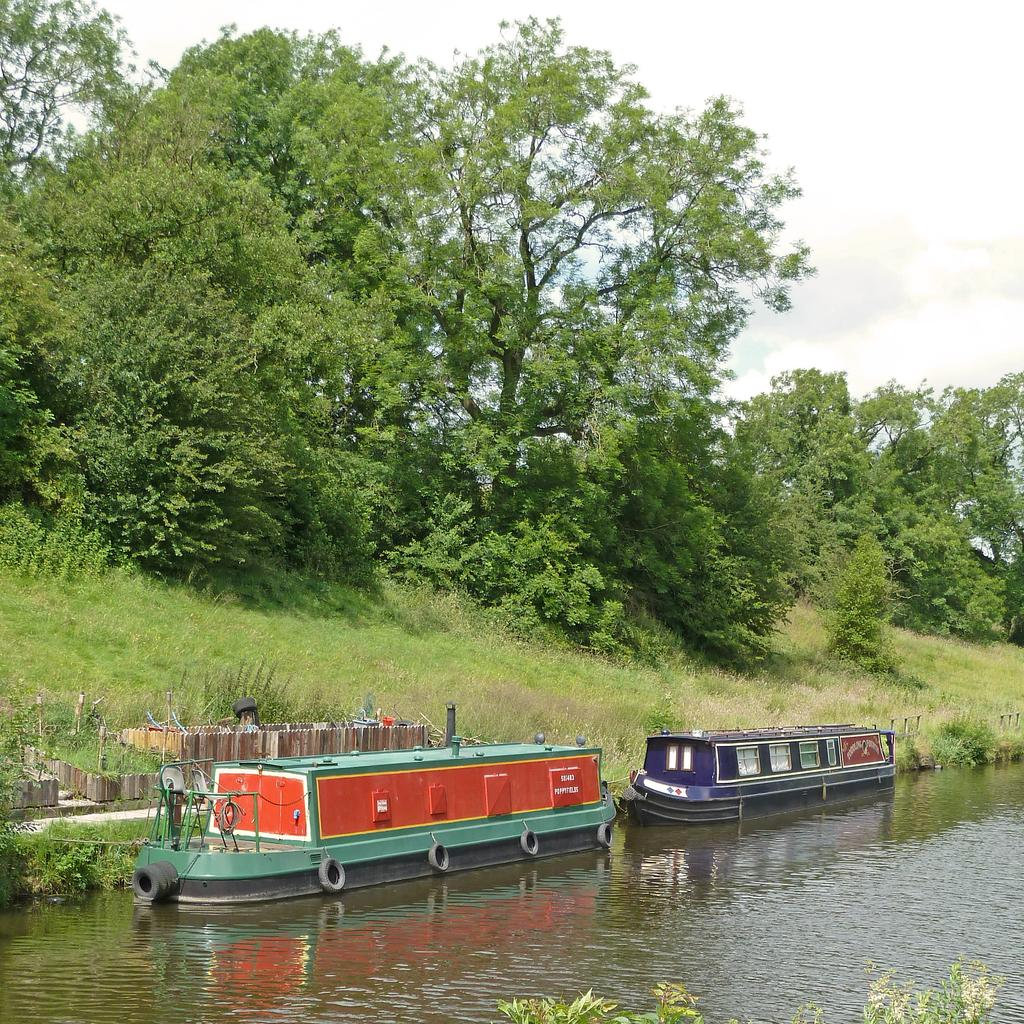What is on the water in the image? There are boats on the water in the image. What type of vegetation can be seen in the image? There are plants and trees visible in the image. What is visible in the background of the image? The sky is visible in the background of the image. How does the support system for the trees work in the image? There is no information provided about the support system for the trees in the image. What is the digestive process of the plants in the image? There is no information provided about the digestive process of the plants in the image. 